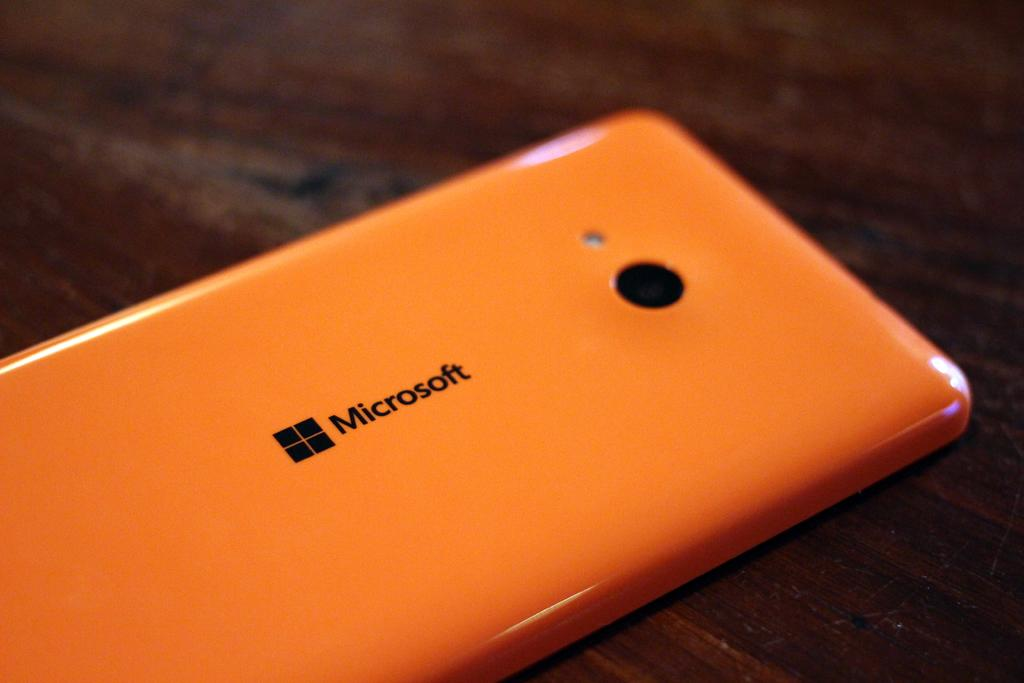<image>
Present a compact description of the photo's key features. Microsoft cellphone that is orange with a camera that is on a table 